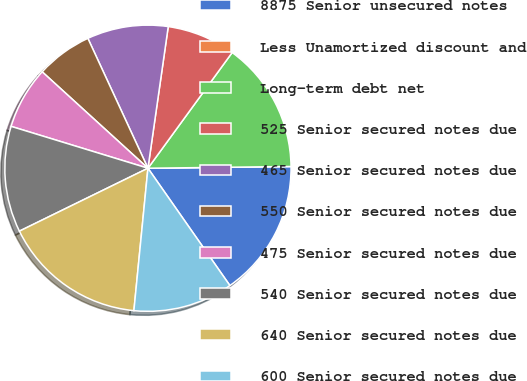<chart> <loc_0><loc_0><loc_500><loc_500><pie_chart><fcel>8875 Senior unsecured notes<fcel>Less Unamortized discount and<fcel>Long-term debt net<fcel>525 Senior secured notes due<fcel>465 Senior secured notes due<fcel>550 Senior secured notes due<fcel>475 Senior secured notes due<fcel>540 Senior secured notes due<fcel>640 Senior secured notes due<fcel>600 Senior secured notes due<nl><fcel>15.49%<fcel>0.0%<fcel>14.79%<fcel>7.75%<fcel>9.16%<fcel>6.34%<fcel>7.04%<fcel>11.97%<fcel>16.19%<fcel>11.27%<nl></chart> 